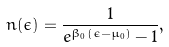<formula> <loc_0><loc_0><loc_500><loc_500>n ( \epsilon ) = \frac { 1 } { e ^ { \beta _ { 0 } ( \epsilon - \mu _ { 0 } ) } - 1 } ,</formula> 